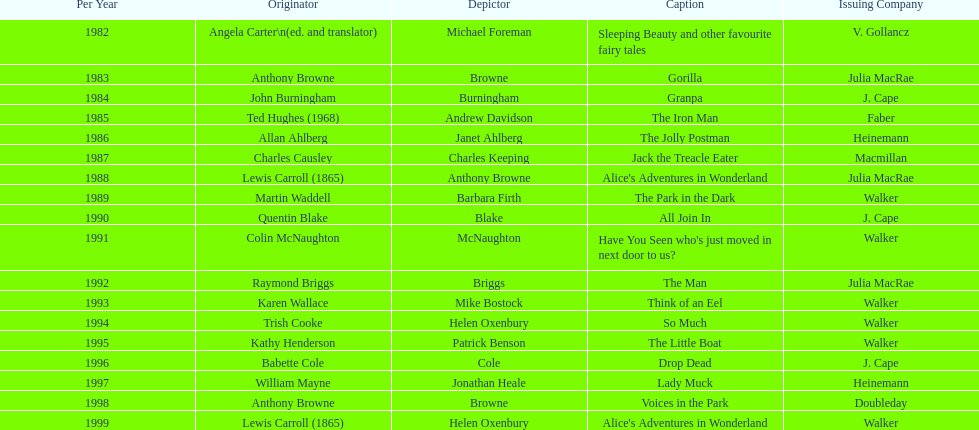Which book won the award a total of 2 times? Alice's Adventures in Wonderland. 